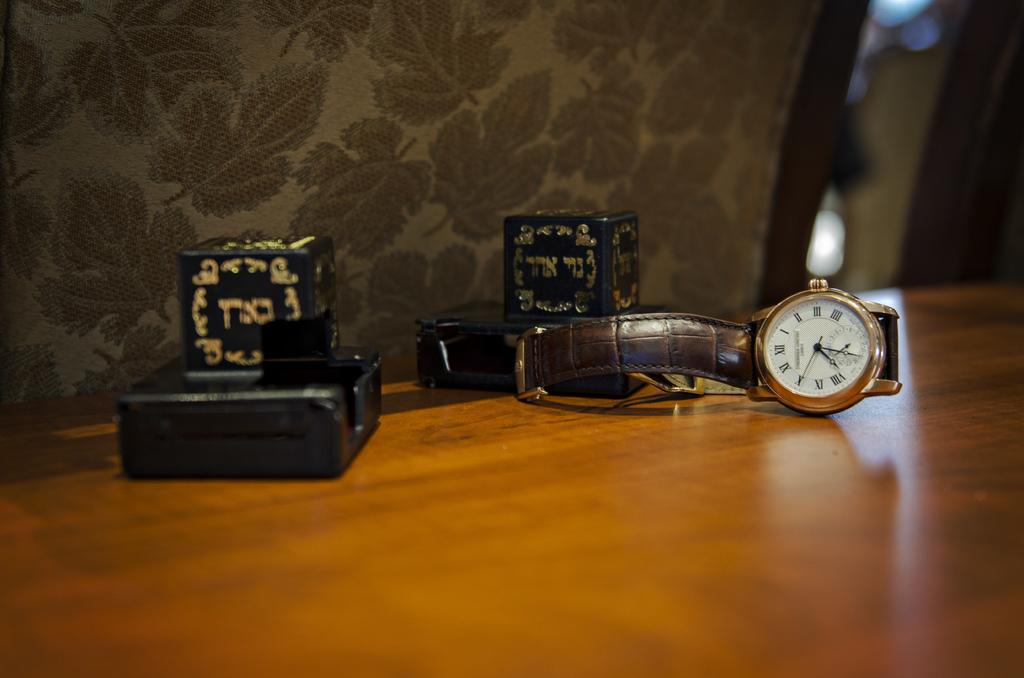<image>
Share a concise interpretation of the image provided. Small wrist watch on a table with the hand on roman numeral "X". 